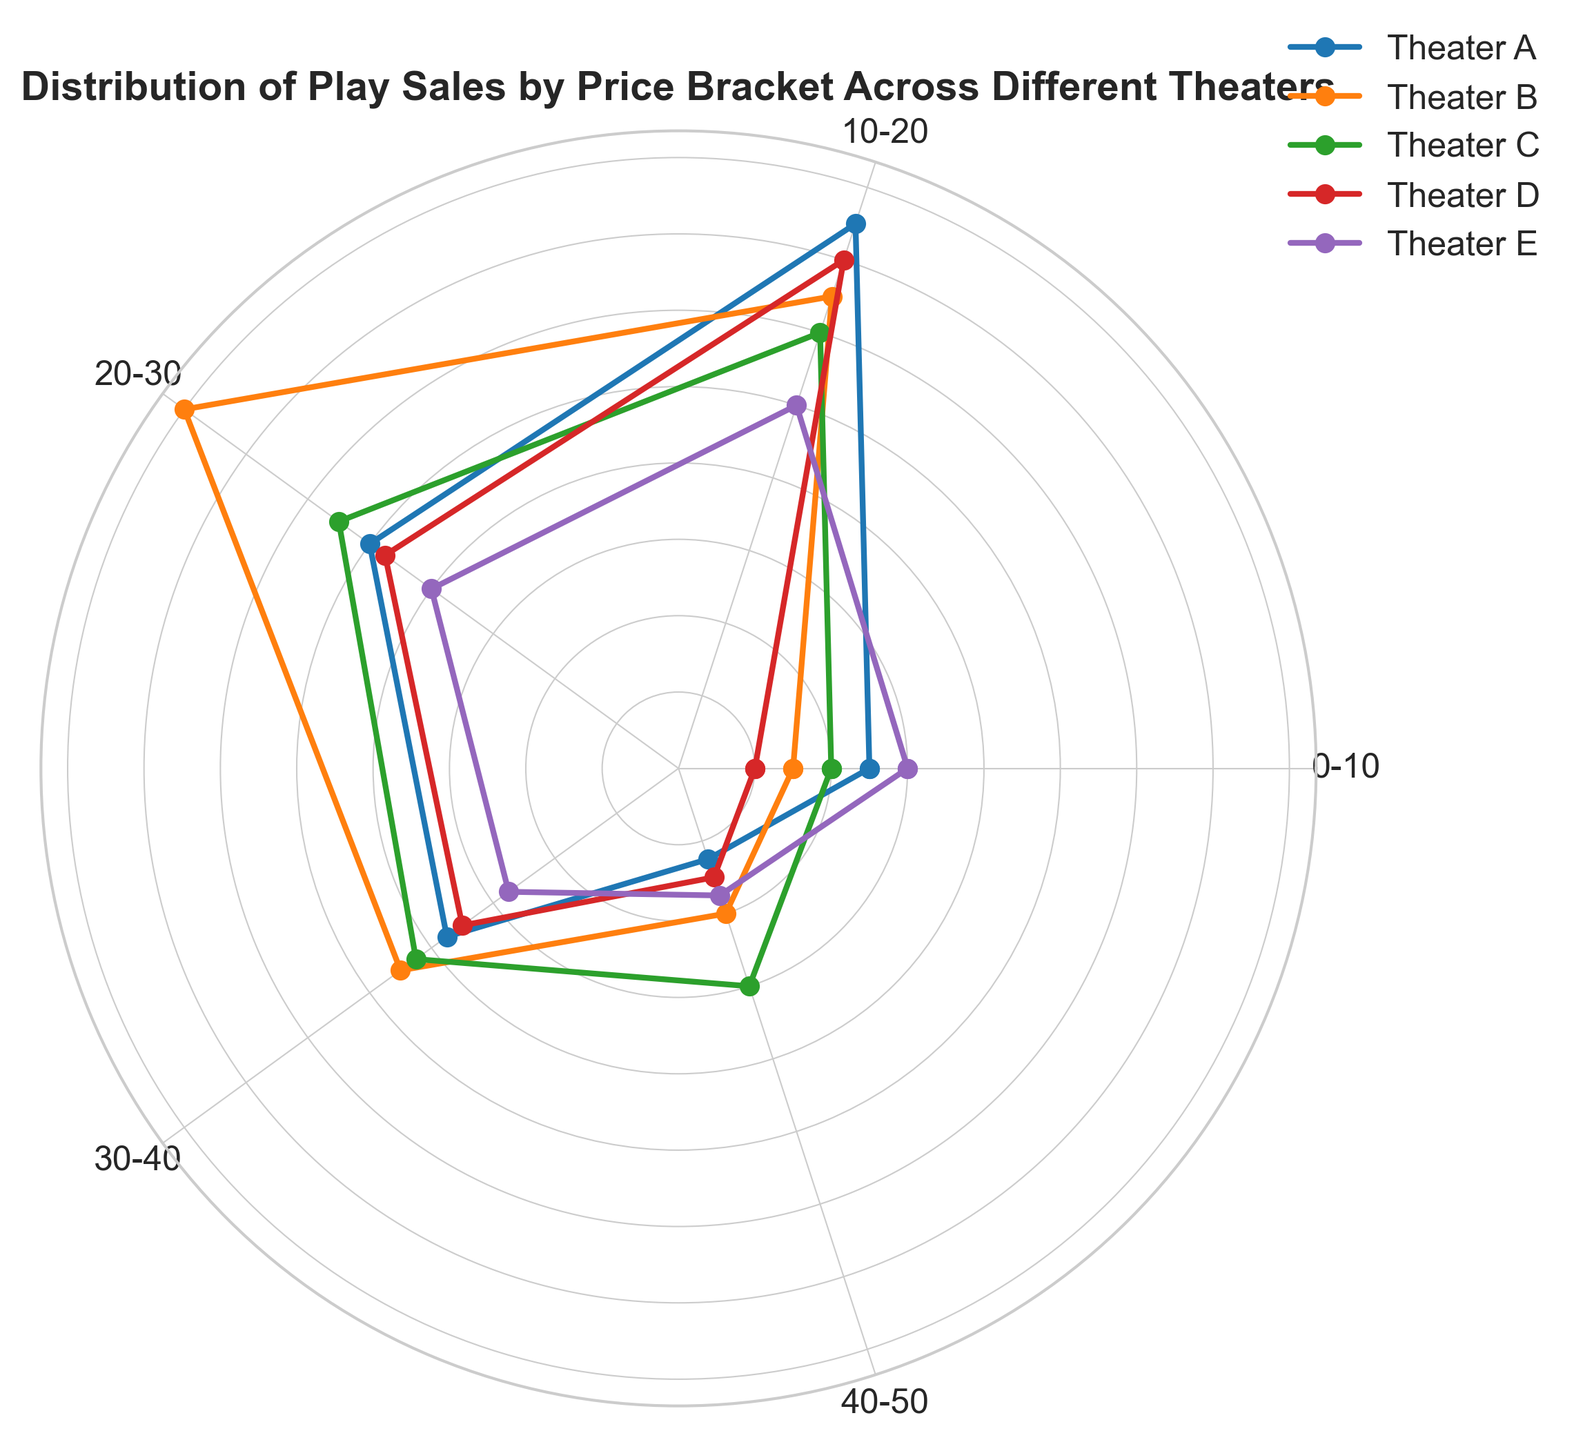Which theater has the highest sales in the 20-30 price bracket? Check the length of the line for each theater in the 20-30 price bracket and compare them. Theater B has the longest line in the 20-30 price bracket.
Answer: Theater B Which price bracket has the least sales for Theater C? Look for the shortest line segment for Theater C (assuming a consistent color coding). The shortest line for Theater C is in the 0-10 price bracket.
Answer: 0-10 How do the sales of Theater E compare to Theater A in the 40-50 price bracket? Compare the lines for Theater E and Theater A in the 40-50 price bracket. Theater E has a longer line (35) than Theater A (25).
Answer: Theater E has higher sales Which price bracket does Theater D excel in the most compared to other theaters? Identify the longest line segment for Theater D and compare it to the same segments for other theaters. Theater D excels the most in the 10-20 price bracket.
Answer: 10-20 What is the total sales for Theater B across all price brackets? Add up the sales of Theater B across all price brackets (30 + 130 + 160 + 90 + 40). (30 + 130 + 160 + 90 + 40 ) = 450.
Answer: 450 In which price bracket do Theaters A and B combined have the highest sales? Sum the sales for Theaters A and B in each price bracket and find the maximum. For 10-20: 150 + 130 = 280, which is the highest combined value.
Answer: 10-20 How does the variation of sales in the 30-40 price bracket across theaters look visually? Inspect the lines in the 30-40 price bracket across all theaters and observe the differences in their lengths. Theater B has the longest, followed by C, A, D, and E. The visual variation shows that Theater B stands out with significantly higher sales in this bracket.
Answer: Theater B stands out with the highest sales What is the average sales for Theater A across all price brackets? Add the sales values for Theater A (50 + 150 + 100 + 75 + 25) and divide by the number of brackets (5).
Answer: 80 Which theater has the most consistent sales across all price brackets? Compare the line lengths for each theater across all price brackets to identify the most uniform lengths. Theater C appears to have the most consistent line lengths.
Answer: Theater C Which price bracket shows the greatest variation in sales among the theaters? Compare the line lengths for all theaters across each price bracket to find the largest visual variability. The 0-10 price bracket shows the greatest variation from 20 to 60.
Answer: 0-10 